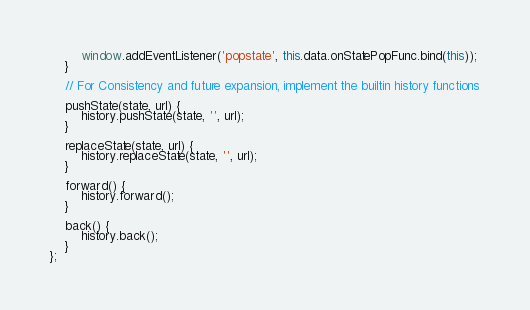Convert code to text. <code><loc_0><loc_0><loc_500><loc_500><_JavaScript_>		window.addEventListener('popstate', this.data.onStatePopFunc.bind(this));
	}

	// For Consistency and future expansion, implement the builtin history functions

	pushState(state, url) {
		history.pushState(state, '', url);
	}

	replaceState(state, url) {
		history.replaceState(state, '', url);
	}

	forward() {
		history.forward();
	}

	back() {
		history.back();
	}
};</code> 